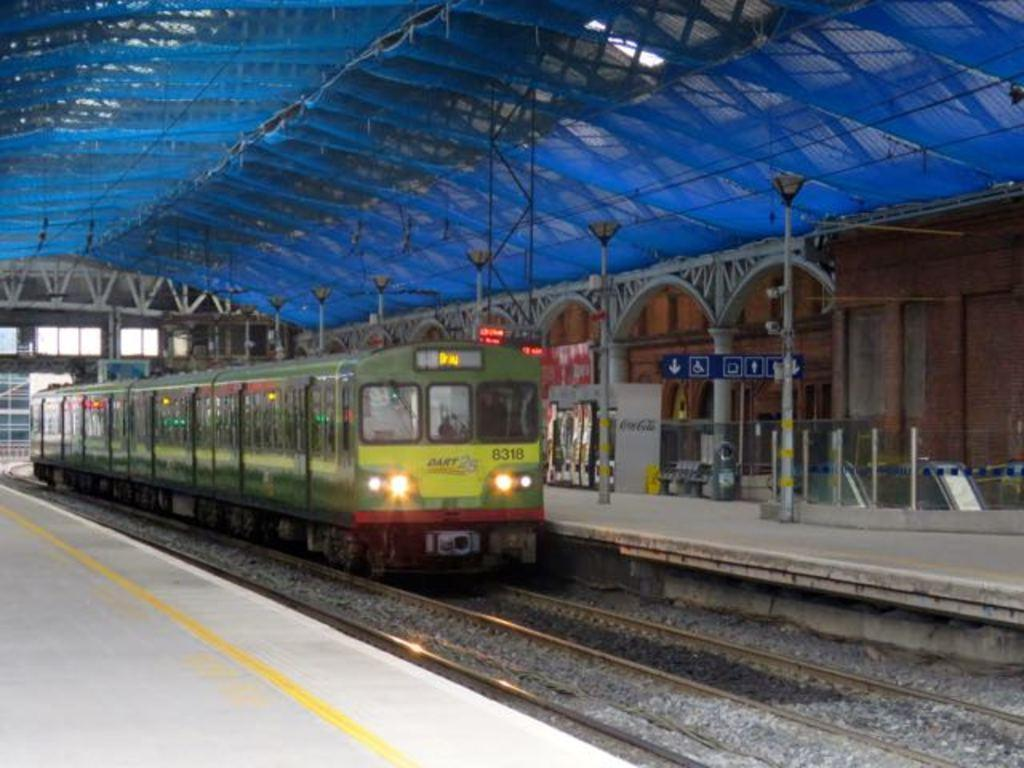What is the main subject of the image? The main subject of the image is a train. What is the train situated on? The train is situated on a railway track. What can be seen near the railway track? There are stones near the railway track. What structure is present in the image for passengers to wait or board the train? There is a platform in the image. What are the poles used for in the image? The poles in the image are likely used for supporting electrical wires or signage. What is the board used for in the image? The board in the image might be used for displaying information or advertisements. What type of prose can be seen on the board in the image? There is no prose visible on the board in the image; it is not a literary work. Can you tell me how many hens are present on the platform in the image? There are no hens present on the platform or anywhere in the image. 